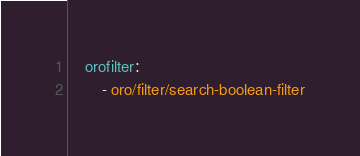<code> <loc_0><loc_0><loc_500><loc_500><_YAML_>    orofilter:
        - oro/filter/search-boolean-filter
</code> 